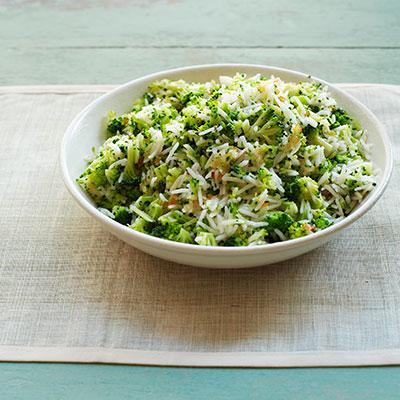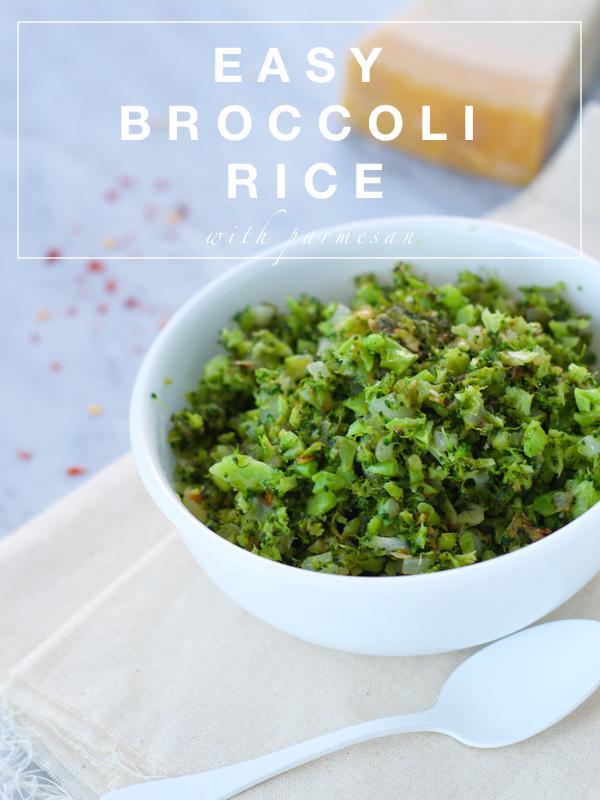The first image is the image on the left, the second image is the image on the right. Assess this claim about the two images: "There is at least one fork clearly visible.". Correct or not? Answer yes or no. No. 